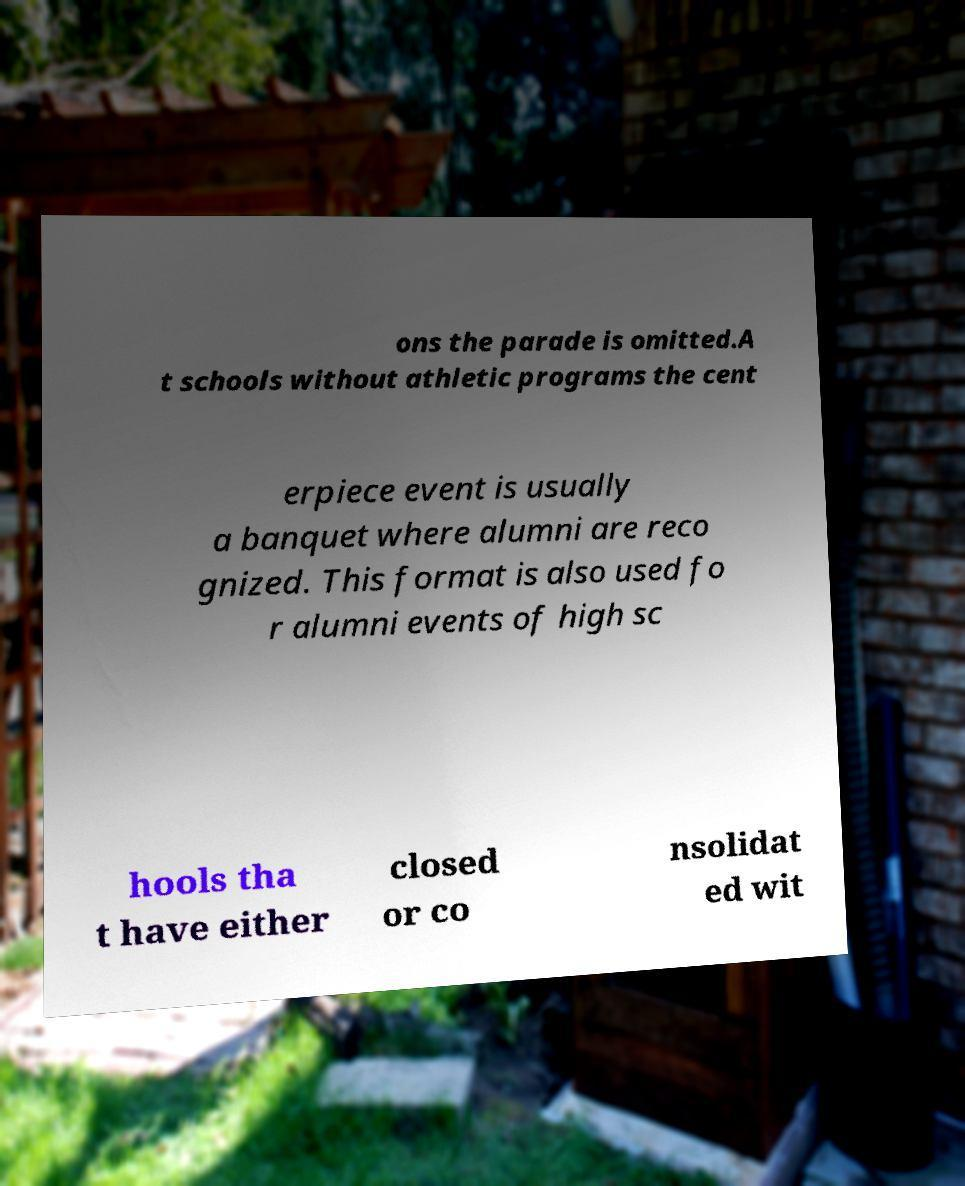For documentation purposes, I need the text within this image transcribed. Could you provide that? ons the parade is omitted.A t schools without athletic programs the cent erpiece event is usually a banquet where alumni are reco gnized. This format is also used fo r alumni events of high sc hools tha t have either closed or co nsolidat ed wit 